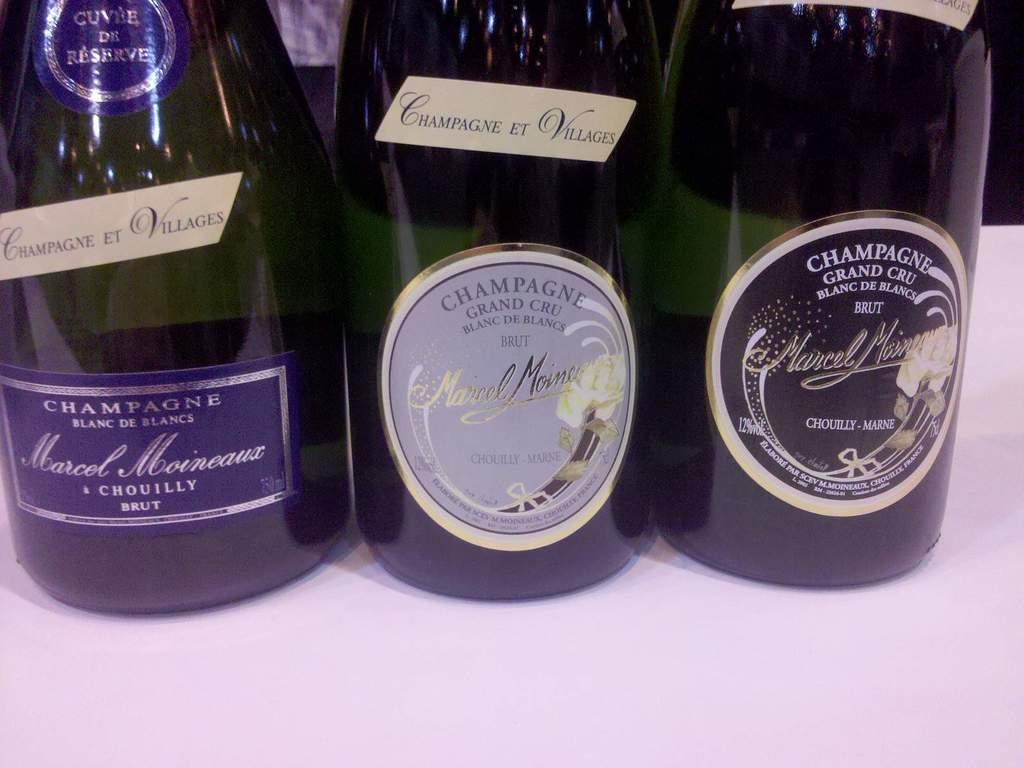<image>
Offer a succinct explanation of the picture presented. 3 bottles of wime called marcel all unopened 